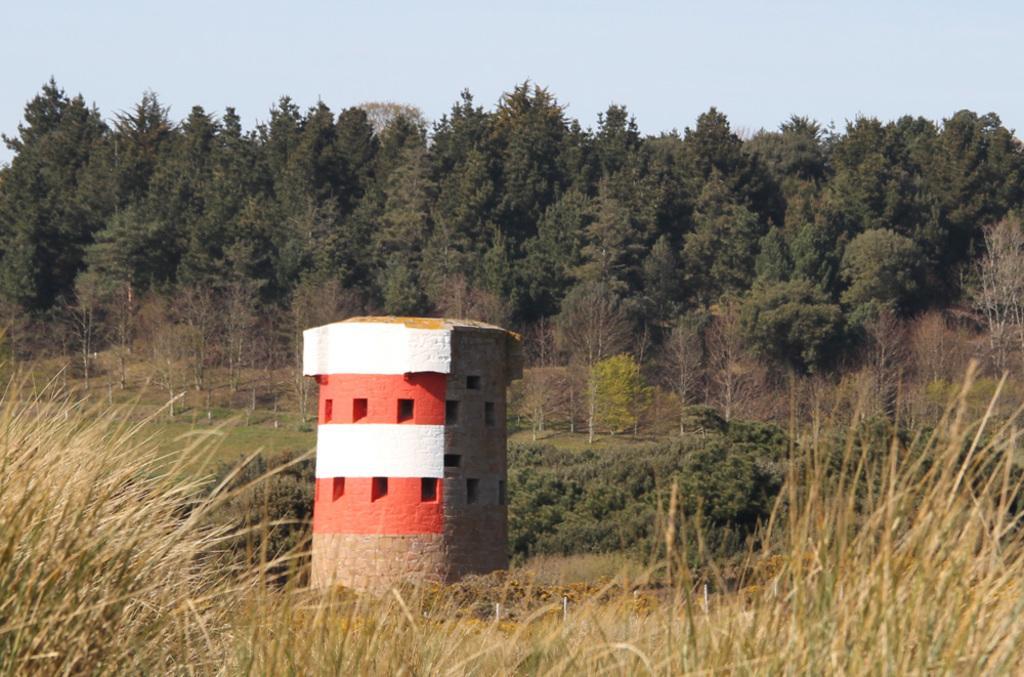Describe this image in one or two sentences. There is tower which is having windows on the ground, on which, there is grass, there are plants and trees. In the background, there is a blue sky. 